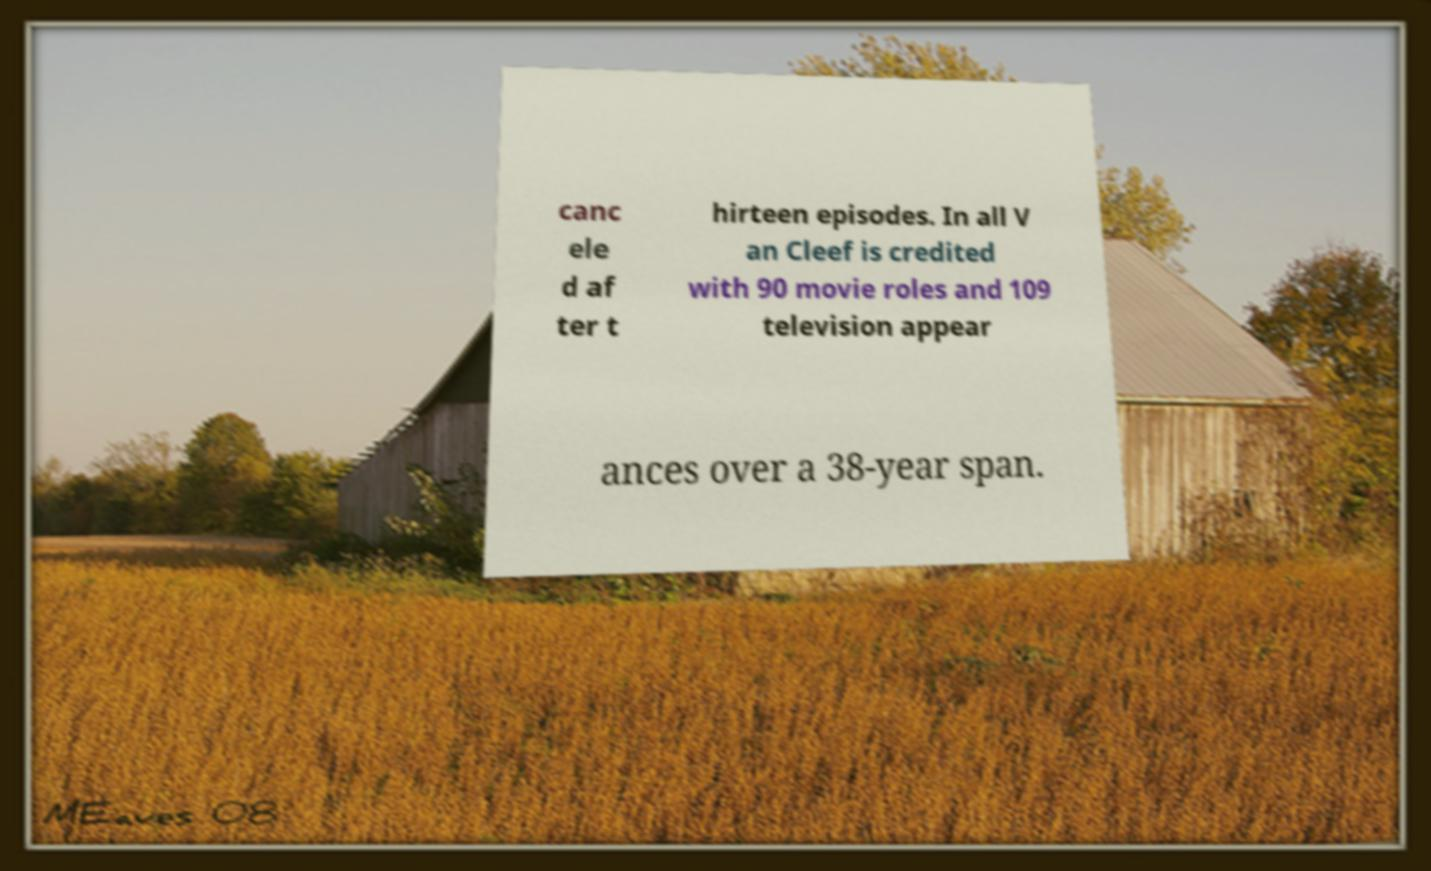Can you read and provide the text displayed in the image?This photo seems to have some interesting text. Can you extract and type it out for me? canc ele d af ter t hirteen episodes. In all V an Cleef is credited with 90 movie roles and 109 television appear ances over a 38-year span. 